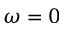<formula> <loc_0><loc_0><loc_500><loc_500>\omega = 0</formula> 